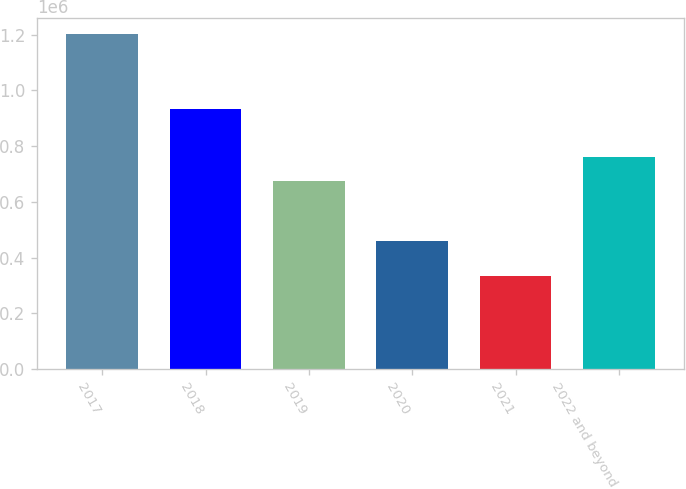Convert chart. <chart><loc_0><loc_0><loc_500><loc_500><bar_chart><fcel>2017<fcel>2018<fcel>2019<fcel>2020<fcel>2021<fcel>2022 and beyond<nl><fcel>1.20109e+06<fcel>934037<fcel>673452<fcel>460178<fcel>334601<fcel>760101<nl></chart> 